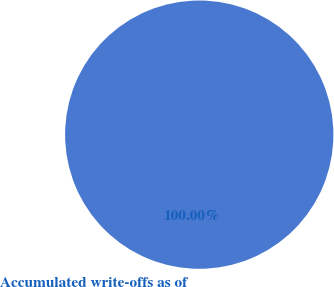Convert chart to OTSL. <chart><loc_0><loc_0><loc_500><loc_500><pie_chart><fcel>Accumulated write-offs as of<nl><fcel>100.0%<nl></chart> 